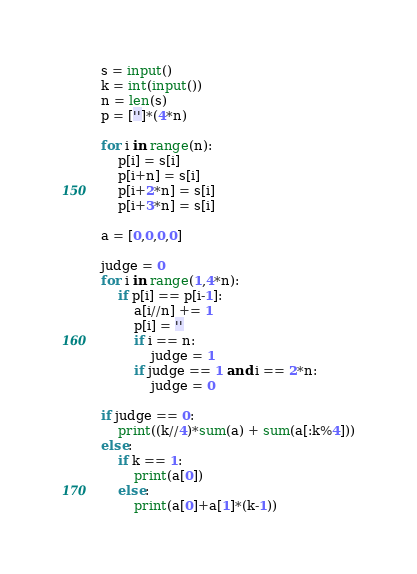<code> <loc_0><loc_0><loc_500><loc_500><_Python_>s = input()
k = int(input())
n = len(s)
p = ['']*(4*n)

for i in range(n):
    p[i] = s[i]
    p[i+n] = s[i]
    p[i+2*n] = s[i]
    p[i+3*n] = s[i]

a = [0,0,0,0]

judge = 0
for i in range(1,4*n):
    if p[i] == p[i-1]:
        a[i//n] += 1
        p[i] = ''
        if i == n:
            judge = 1
        if judge == 1 and i == 2*n:
            judge = 0

if judge == 0:
    print((k//4)*sum(a) + sum(a[:k%4]))
else:
    if k == 1:
        print(a[0])
    else:
        print(a[0]+a[1]*(k-1))</code> 